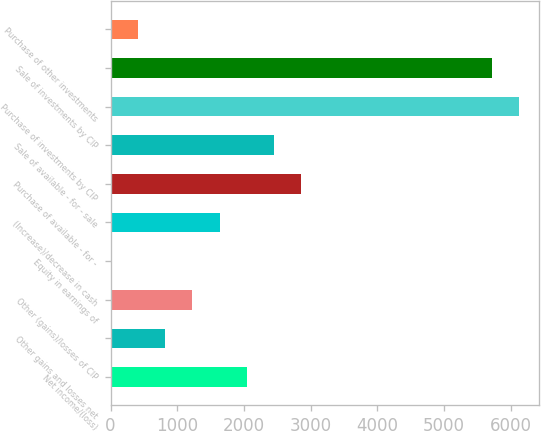Convert chart to OTSL. <chart><loc_0><loc_0><loc_500><loc_500><bar_chart><fcel>Net income/(loss)<fcel>Other gains and losses net<fcel>Other (gains)/losses of CIP<fcel>Equity in earnings of<fcel>(Increase)/decrease in cash<fcel>Purchase of available - for -<fcel>Sale of available - for - sale<fcel>Purchase of investments by CIP<fcel>Sale of investments by CIP<fcel>Purchase of other investments<nl><fcel>2041.2<fcel>817.5<fcel>1225.4<fcel>1.7<fcel>1633.3<fcel>2857<fcel>2449.1<fcel>6120.2<fcel>5712.3<fcel>409.6<nl></chart> 